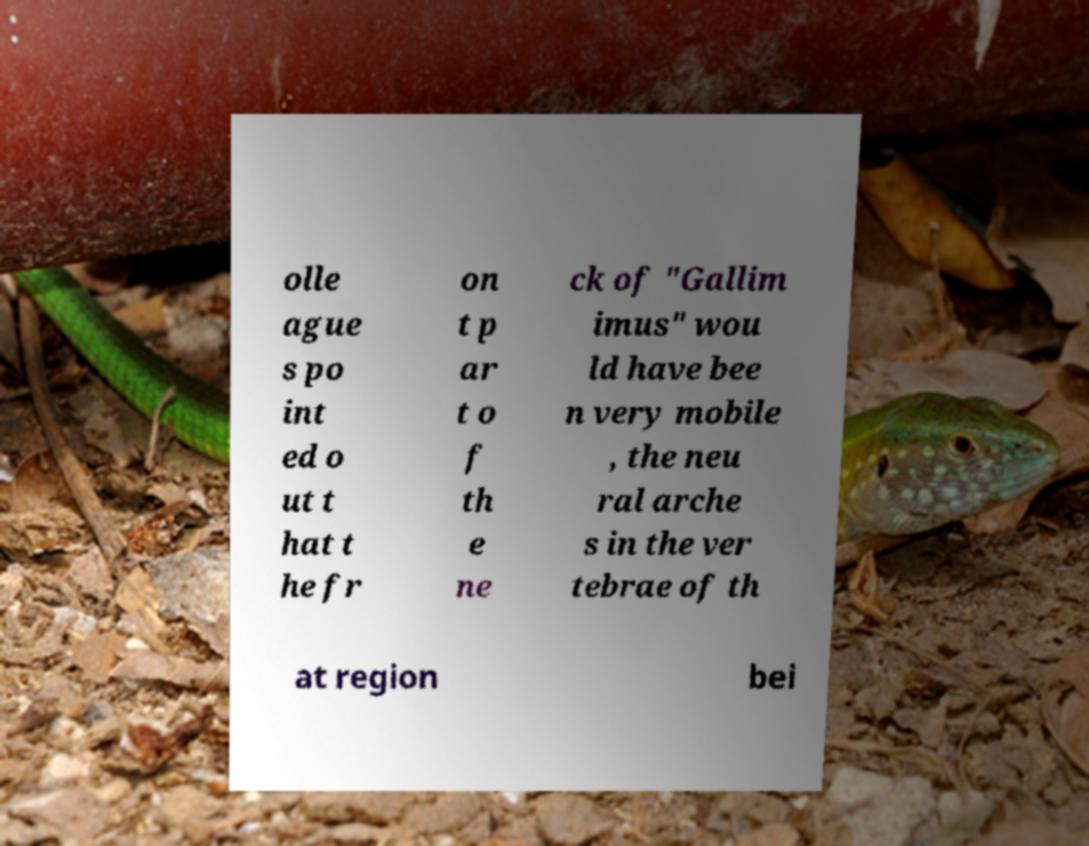For documentation purposes, I need the text within this image transcribed. Could you provide that? olle ague s po int ed o ut t hat t he fr on t p ar t o f th e ne ck of "Gallim imus" wou ld have bee n very mobile , the neu ral arche s in the ver tebrae of th at region bei 